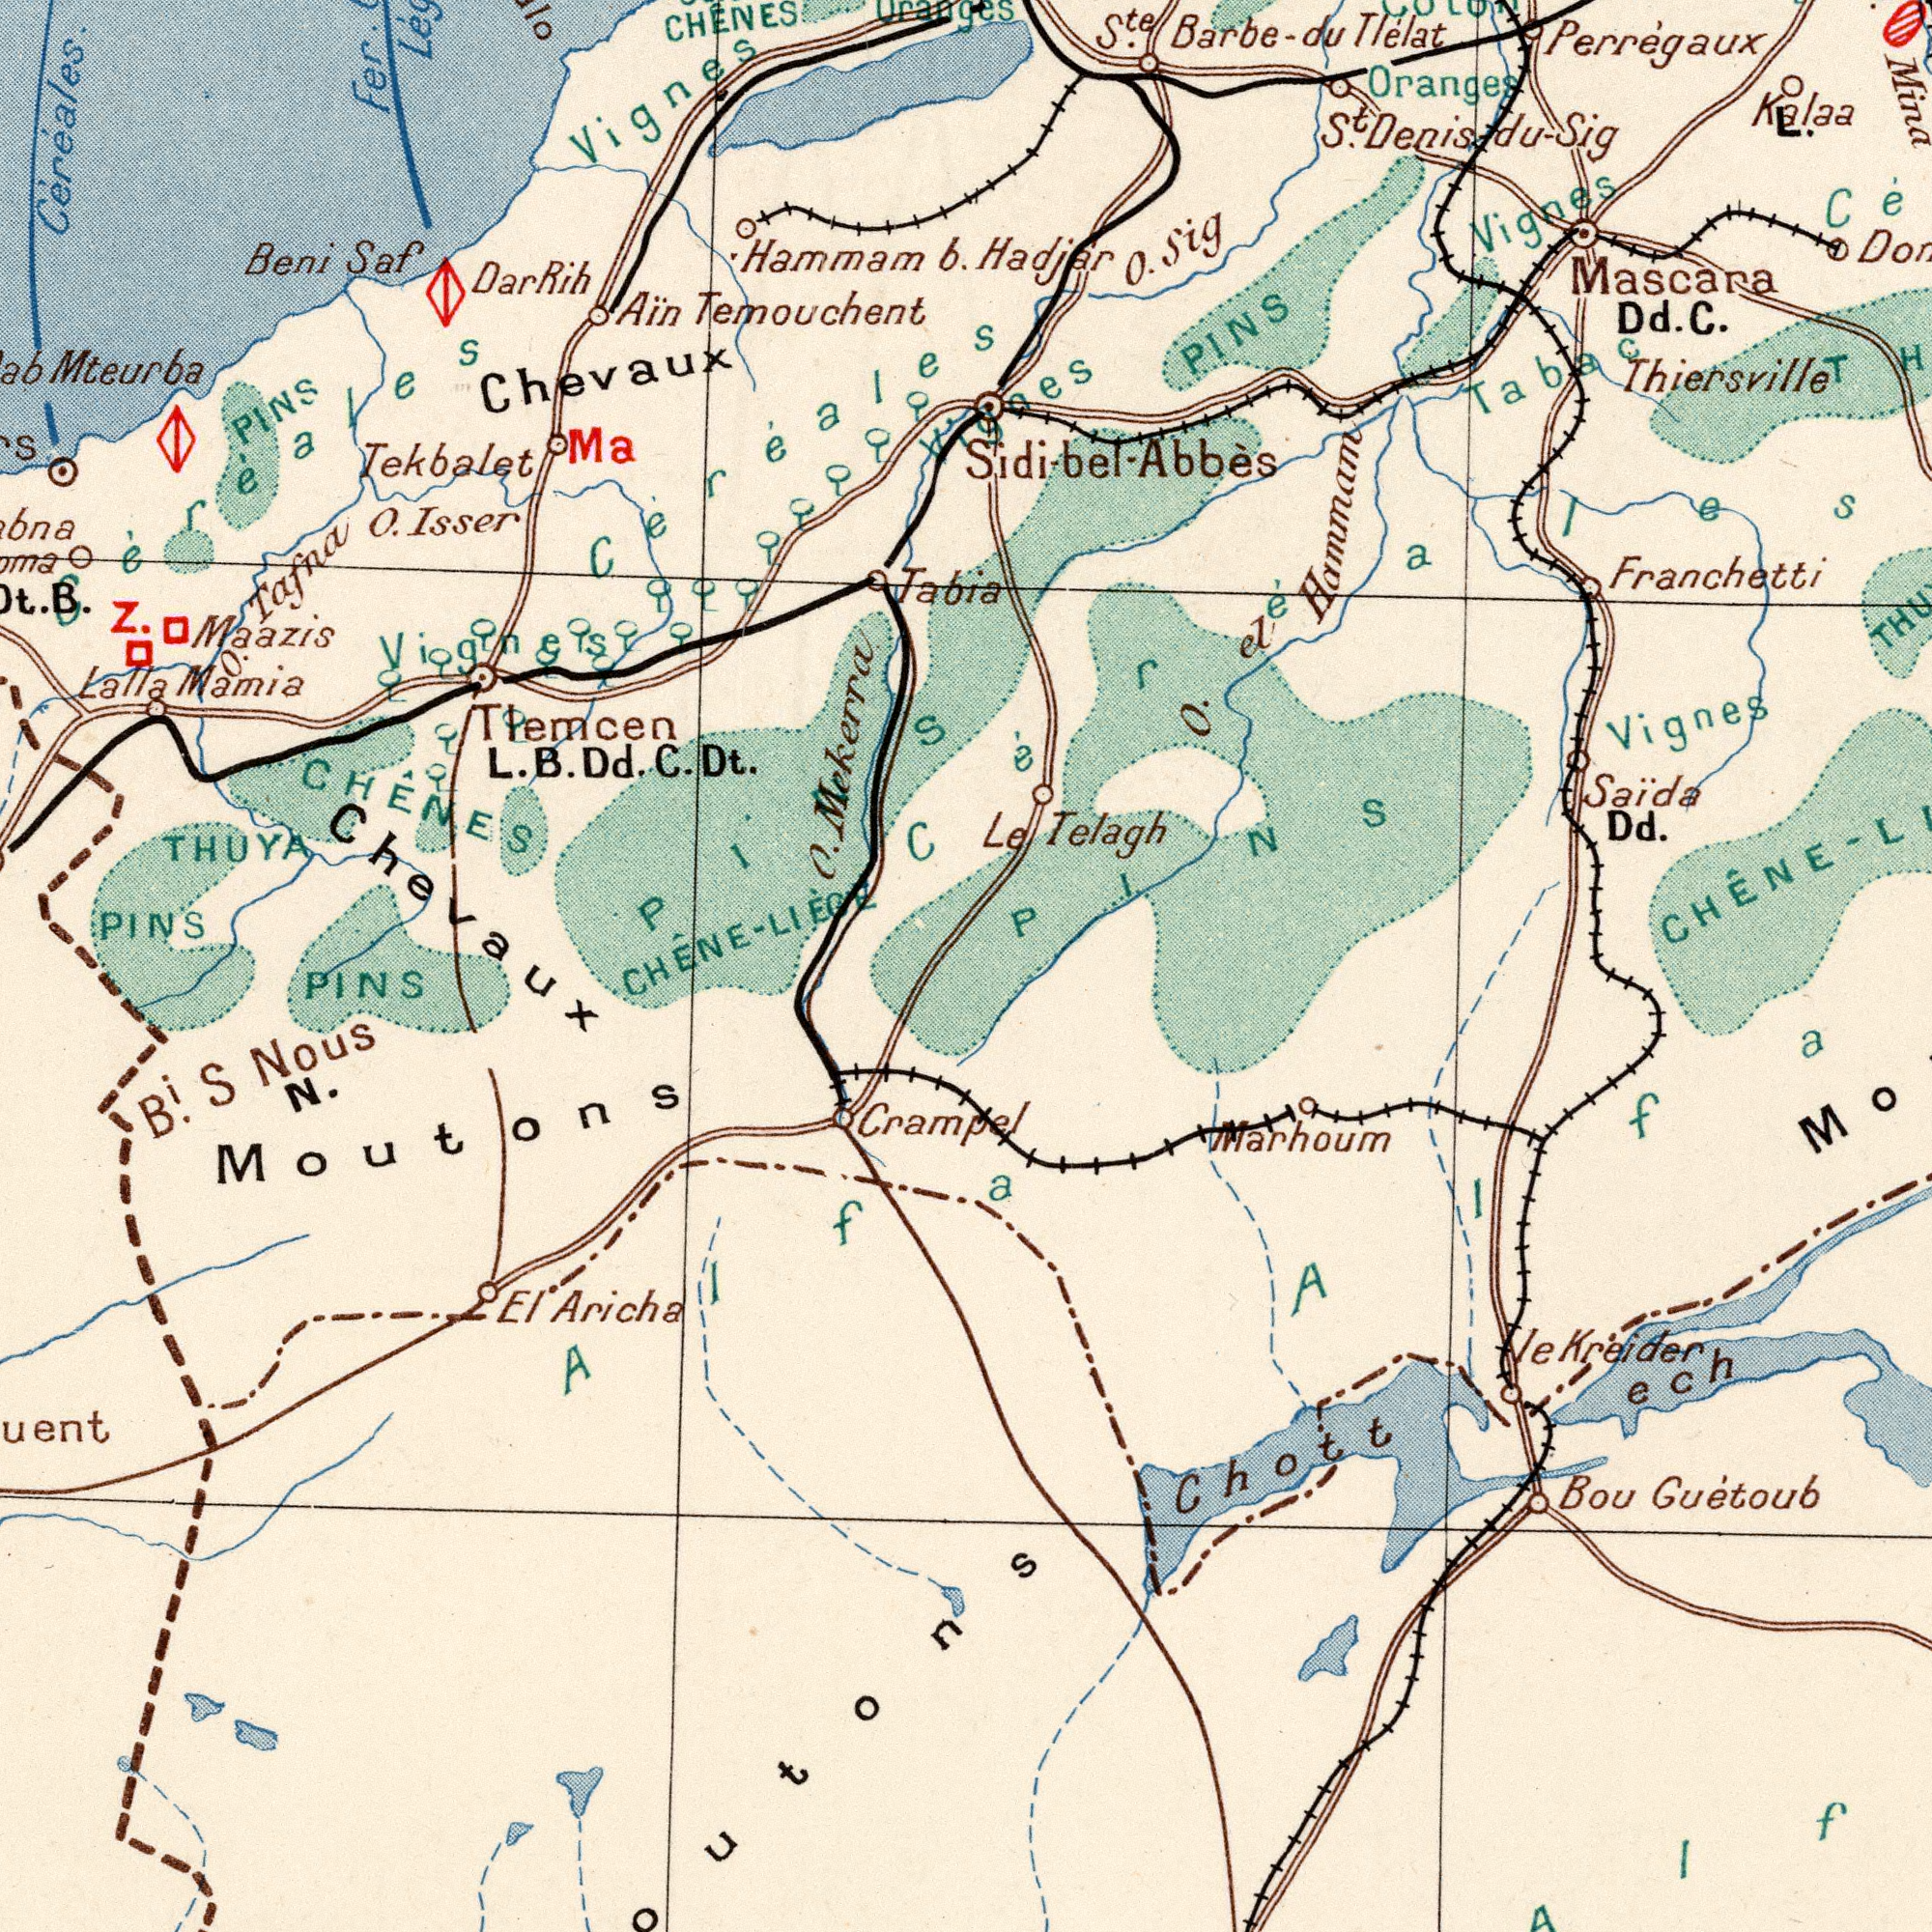What text appears in the top-right area of the image? Hadjar Oranges Franchetti Mascara Dd. C. Thiersville Perrégaux Kalaa PINS O. el Hammam S<sup>te</sup>. Barbe-du Tlélat Vignes Mina O. Sig S<sup>t</sup>. Denisidu - Sig Vignes Tabac Sidi-bel - Abbės gaes Céréales L. What text is shown in the bottom-right quadrant? Le Telagh Saida Dd. CHÊNE- Marhoum Bou Guėtoub Chott le Kreider ech Alfa PINS What text is shown in the bottom-left quadrant? PINS C. L. B. Dd. C. THUYA CHÊNE-LIÊGE Chevaux CHÊNES PINS El Aricha N. Moutons Crampe B<sup>i</sup>. S Nous Alfa PINS What text appears in the top-left area of the image? Maazis Lalla Mamia Tekbalet Céréales. Mteurba Mekerra Beni Saf CHENES Tlemcen Dt. Tafna O. Isser Hammam b. Ain Temouchent Ma Z. Jabia PINS B. Fer. Lég Vignes Chevaux Vignes Céréales Céréales Dar Rih Uranges 